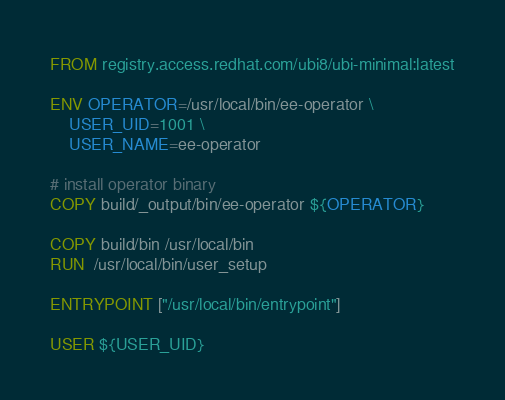<code> <loc_0><loc_0><loc_500><loc_500><_Dockerfile_>FROM registry.access.redhat.com/ubi8/ubi-minimal:latest

ENV OPERATOR=/usr/local/bin/ee-operator \
    USER_UID=1001 \
    USER_NAME=ee-operator

# install operator binary
COPY build/_output/bin/ee-operator ${OPERATOR}

COPY build/bin /usr/local/bin
RUN  /usr/local/bin/user_setup

ENTRYPOINT ["/usr/local/bin/entrypoint"]

USER ${USER_UID}
</code> 